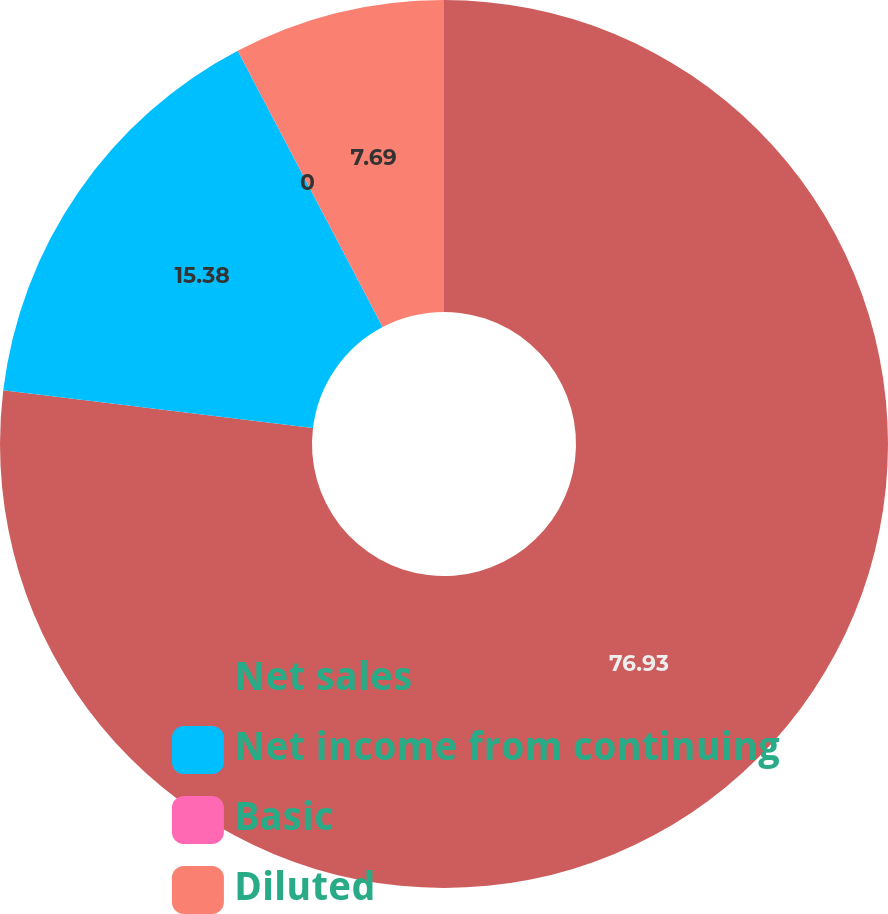Convert chart. <chart><loc_0><loc_0><loc_500><loc_500><pie_chart><fcel>Net sales<fcel>Net income from continuing<fcel>Basic<fcel>Diluted<nl><fcel>76.92%<fcel>15.38%<fcel>0.0%<fcel>7.69%<nl></chart> 